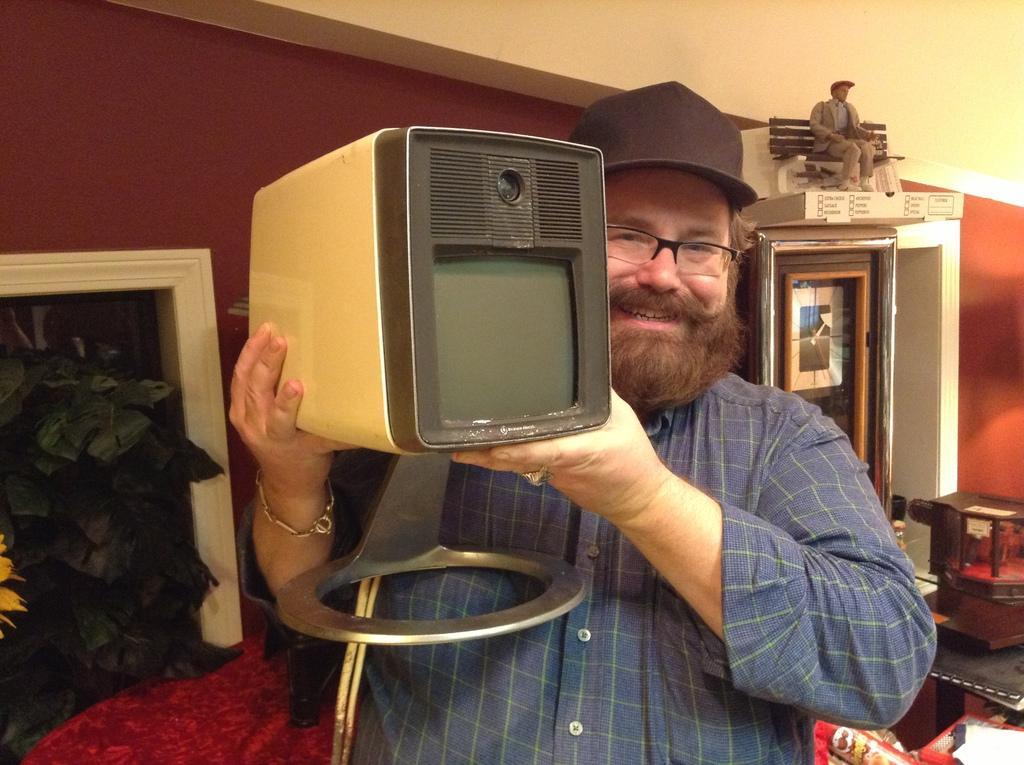Describe this image in one or two sentences. In the image we can see a man standing, wearing clothes, cap, spectacles, bracelet and the man is holding an electronic device in the hands. Here we can see leaves, wall and toy of a person. 